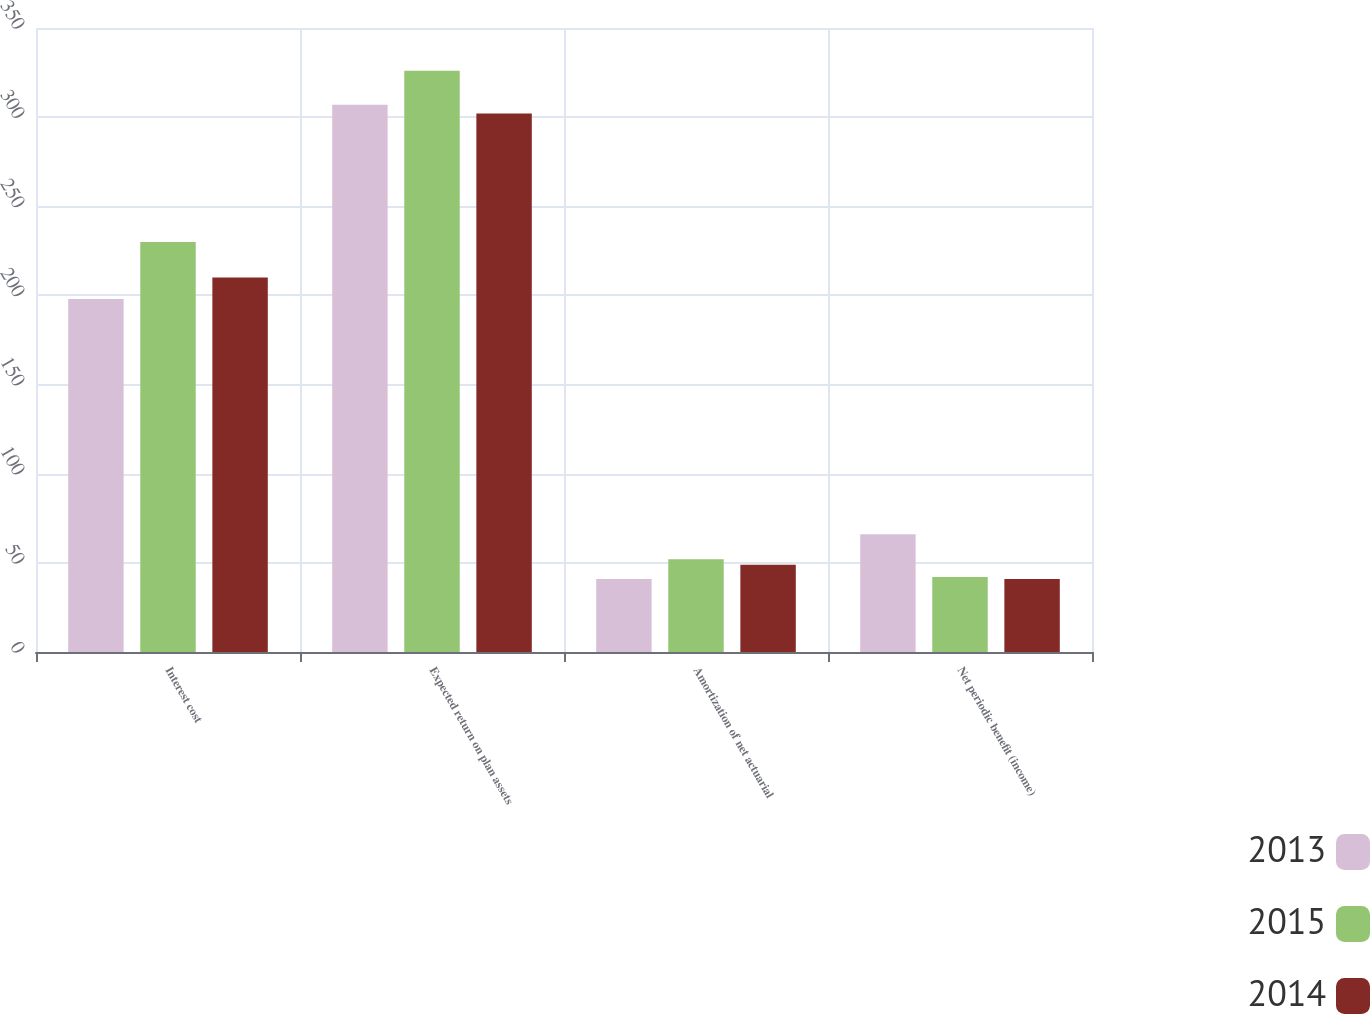<chart> <loc_0><loc_0><loc_500><loc_500><stacked_bar_chart><ecel><fcel>Interest cost<fcel>Expected return on plan assets<fcel>Amortization of net actuarial<fcel>Net periodic benefit (income)<nl><fcel>2013<fcel>198<fcel>307<fcel>41<fcel>66<nl><fcel>2015<fcel>230<fcel>326<fcel>52<fcel>42<nl><fcel>2014<fcel>210<fcel>302<fcel>49<fcel>41<nl></chart> 